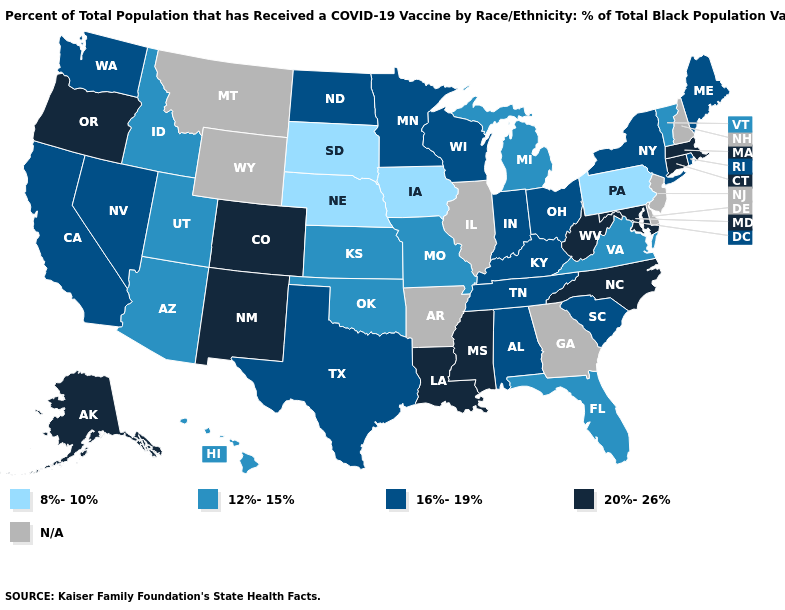What is the value of Nebraska?
Quick response, please. 8%-10%. Does the map have missing data?
Concise answer only. Yes. What is the value of Georgia?
Short answer required. N/A. What is the lowest value in the USA?
Be succinct. 8%-10%. What is the highest value in states that border Kentucky?
Give a very brief answer. 20%-26%. Among the states that border Texas , does Oklahoma have the highest value?
Write a very short answer. No. Does Nebraska have the lowest value in the MidWest?
Give a very brief answer. Yes. What is the value of Tennessee?
Be succinct. 16%-19%. How many symbols are there in the legend?
Quick response, please. 5. What is the highest value in the USA?
Keep it brief. 20%-26%. Which states have the lowest value in the South?
Be succinct. Florida, Oklahoma, Virginia. What is the value of Idaho?
Keep it brief. 12%-15%. Name the states that have a value in the range N/A?
Write a very short answer. Arkansas, Delaware, Georgia, Illinois, Montana, New Hampshire, New Jersey, Wyoming. How many symbols are there in the legend?
Keep it brief. 5. Name the states that have a value in the range 8%-10%?
Write a very short answer. Iowa, Nebraska, Pennsylvania, South Dakota. 